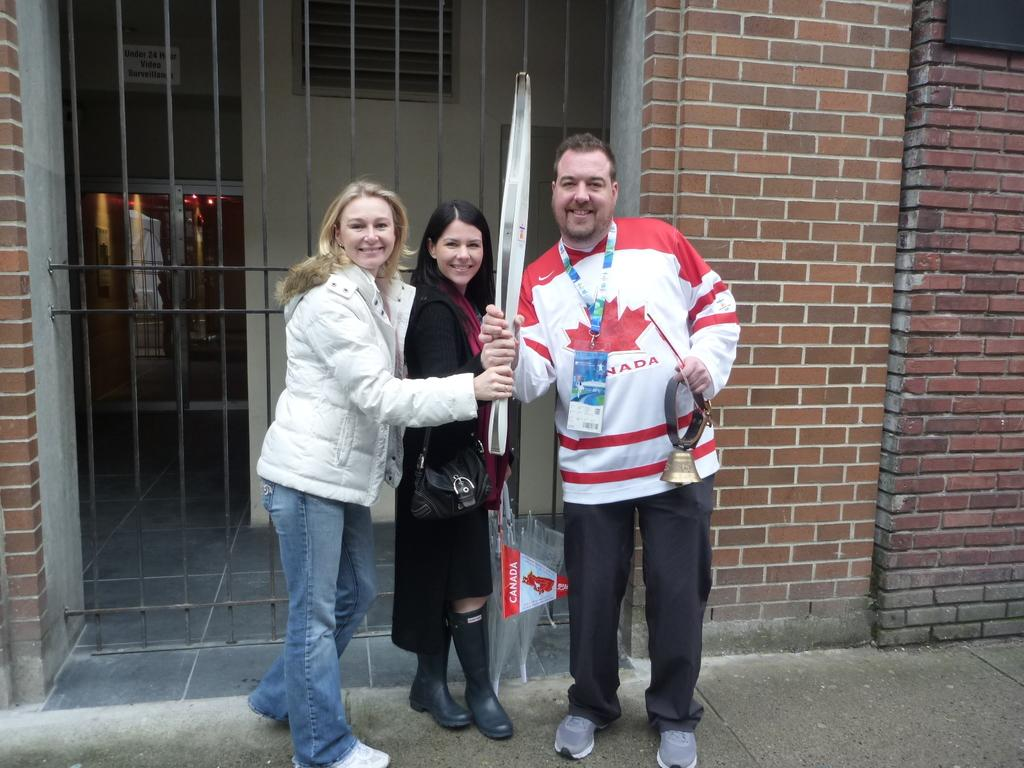Who or what can be seen in the image? There are people in the image. What is the background of the image? The people are standing in front of a building. What are the people holding in the image? The people are holding an object. What language is being spoken by the people in the image? The provided facts do not mention any language being spoken, so it cannot be determined from the image. 